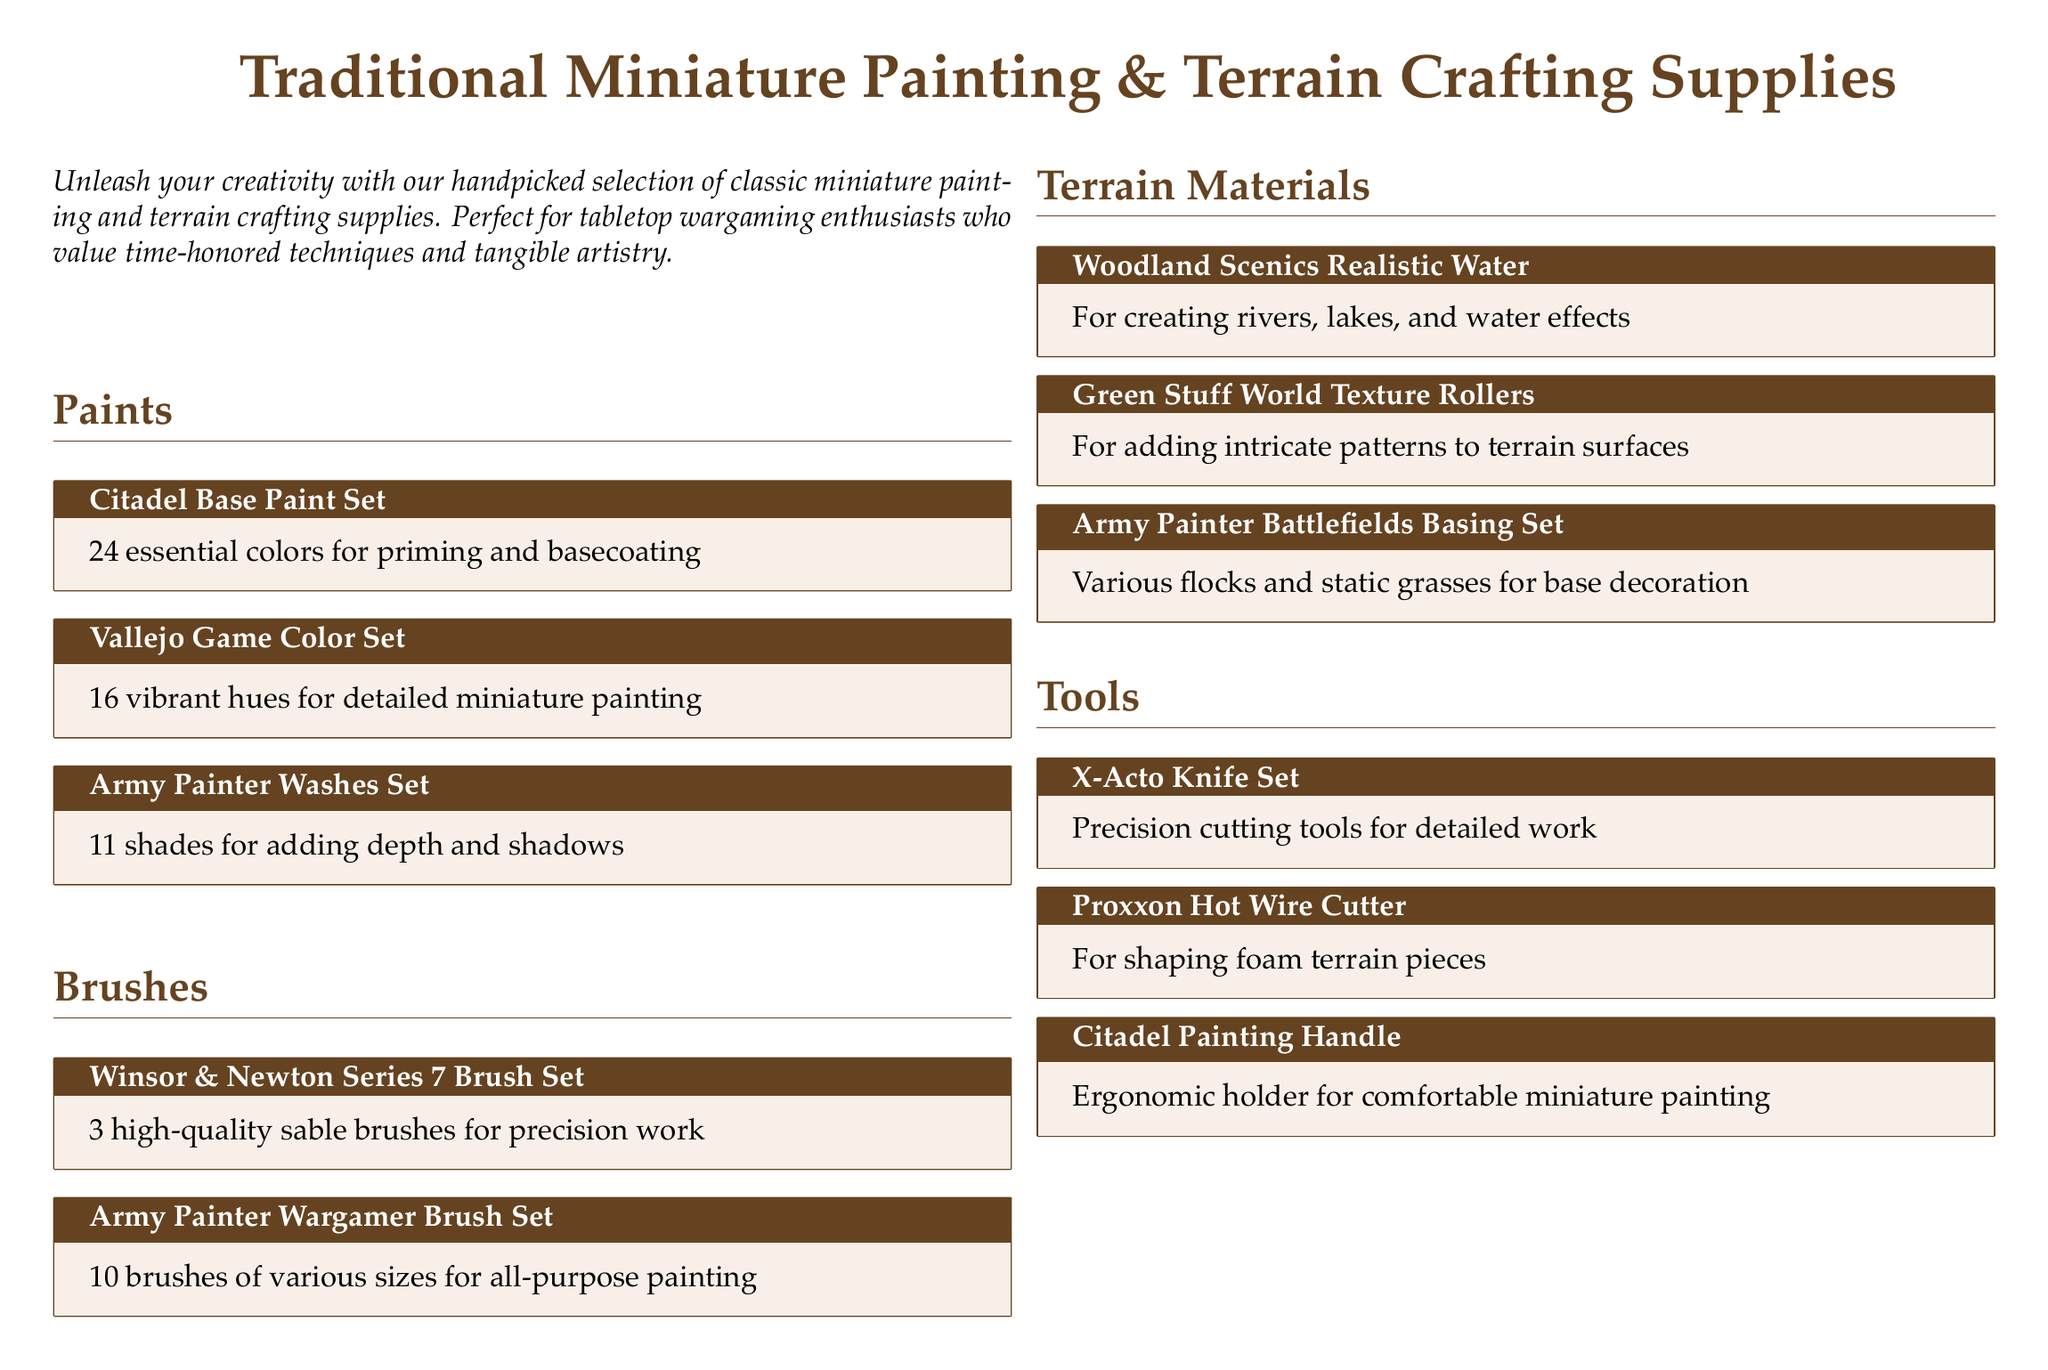What are the essential colors included in the Citadel Base Paint Set? The Citadel Base Paint Set includes 24 essential colors for priming and basecoating.
Answer: 24 essential colors How many brushes are in the Army Painter Wargamer Brush Set? The Army Painter Wargamer Brush Set contains 10 brushes of various sizes for all-purpose painting.
Answer: 10 brushes What is the primary use of Woodland Scenics Realistic Water? Woodland Scenics Realistic Water is used for creating rivers, lakes, and water effects.
Answer: Creating water effects What is included in the Army Painter Battlefields Basing Set? The Army Painter Battlefields Basing Set includes various flocks and static grasses for base decoration.
Answer: Various flocks and static grasses Which brush set is known for precision work? The Winsor & Newton Series 7 Brush Set is known for precision work.
Answer: Winsor & Newton Series 7 Brush Set How many shades does the Army Painter Washes Set feature? The Army Painter Washes Set features 11 shades for adding depth and shadows.
Answer: 11 shades What tool is used for shaping foam terrain pieces? The Proxxon Hot Wire Cutter is used for shaping foam terrain pieces.
Answer: Proxxon Hot Wire Cutter What type of cutting tools does the X-Acto Knife Set include? The X-Acto Knife Set includes precision cutting tools for detailed work.
Answer: Precision cutting tools What is emphasized in the document about the approach to crafting? The document emphasizes embracing the artisan's approach to miniature painting and terrain crafting.
Answer: Artisan's approach 